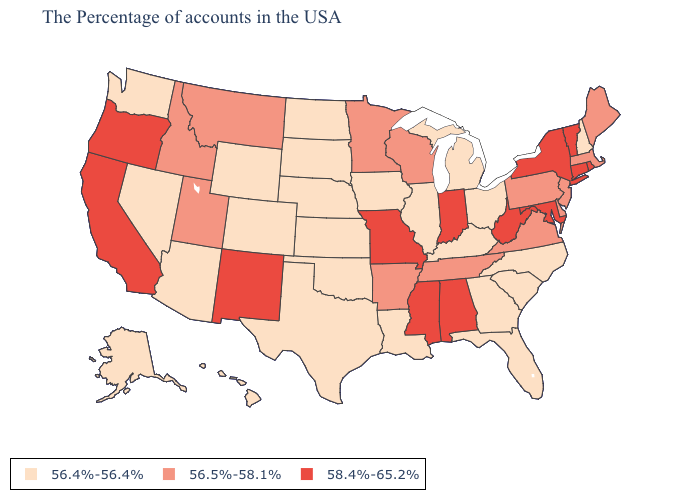What is the highest value in the USA?
Concise answer only. 58.4%-65.2%. What is the lowest value in the USA?
Answer briefly. 56.4%-56.4%. Does Indiana have the same value as Wisconsin?
Answer briefly. No. What is the value of New Mexico?
Keep it brief. 58.4%-65.2%. Name the states that have a value in the range 58.4%-65.2%?
Concise answer only. Rhode Island, Vermont, Connecticut, New York, Maryland, West Virginia, Indiana, Alabama, Mississippi, Missouri, New Mexico, California, Oregon. What is the value of Ohio?
Short answer required. 56.4%-56.4%. Is the legend a continuous bar?
Answer briefly. No. What is the value of New Mexico?
Be succinct. 58.4%-65.2%. What is the value of Vermont?
Concise answer only. 58.4%-65.2%. Which states have the lowest value in the USA?
Quick response, please. New Hampshire, North Carolina, South Carolina, Ohio, Florida, Georgia, Michigan, Kentucky, Illinois, Louisiana, Iowa, Kansas, Nebraska, Oklahoma, Texas, South Dakota, North Dakota, Wyoming, Colorado, Arizona, Nevada, Washington, Alaska, Hawaii. Does Rhode Island have the highest value in the USA?
Quick response, please. Yes. Name the states that have a value in the range 58.4%-65.2%?
Short answer required. Rhode Island, Vermont, Connecticut, New York, Maryland, West Virginia, Indiana, Alabama, Mississippi, Missouri, New Mexico, California, Oregon. Does the first symbol in the legend represent the smallest category?
Give a very brief answer. Yes. What is the lowest value in states that border Nevada?
Give a very brief answer. 56.4%-56.4%. What is the value of California?
Concise answer only. 58.4%-65.2%. 